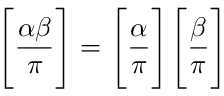<formula> <loc_0><loc_0><loc_500><loc_500>{ \left [ } { \frac { \alpha \beta } { \pi } } { \right ] } = { \left [ } { \frac { \alpha } { \pi } } { \right ] } { \left [ } { \frac { \beta } { \pi } } { \right ] }</formula> 